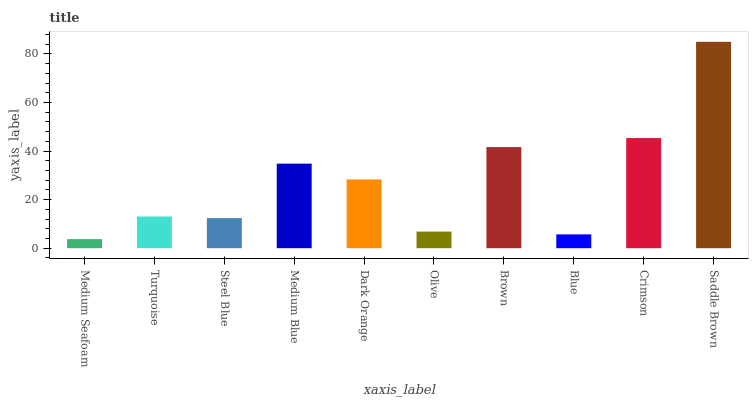Is Medium Seafoam the minimum?
Answer yes or no. Yes. Is Saddle Brown the maximum?
Answer yes or no. Yes. Is Turquoise the minimum?
Answer yes or no. No. Is Turquoise the maximum?
Answer yes or no. No. Is Turquoise greater than Medium Seafoam?
Answer yes or no. Yes. Is Medium Seafoam less than Turquoise?
Answer yes or no. Yes. Is Medium Seafoam greater than Turquoise?
Answer yes or no. No. Is Turquoise less than Medium Seafoam?
Answer yes or no. No. Is Dark Orange the high median?
Answer yes or no. Yes. Is Turquoise the low median?
Answer yes or no. Yes. Is Saddle Brown the high median?
Answer yes or no. No. Is Steel Blue the low median?
Answer yes or no. No. 